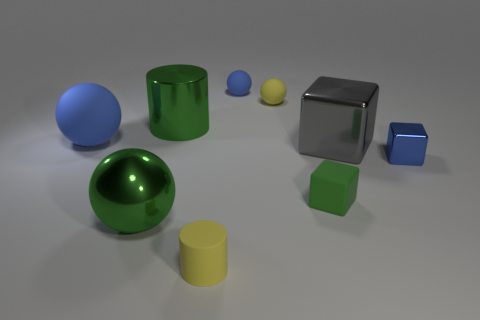Is the shape of the blue object that is to the left of the small blue matte ball the same as the yellow object that is behind the tiny yellow cylinder?
Ensure brevity in your answer.  Yes. What shape is the big object right of the cylinder that is in front of the large gray shiny block?
Your answer should be compact. Cube. There is a shiny thing that is right of the tiny green cube and behind the tiny metal block; what size is it?
Your answer should be very brief. Large. Is the shape of the large blue thing the same as the yellow matte object behind the big green sphere?
Provide a succinct answer. Yes. There is a green object that is the same shape as the gray thing; what size is it?
Your answer should be compact. Small. There is a large cube; does it have the same color as the cylinder that is behind the yellow cylinder?
Ensure brevity in your answer.  No. What number of other things are there of the same size as the blue metal object?
Give a very brief answer. 4. The tiny yellow thing that is to the right of the blue rubber sphere that is on the right side of the large green metal object in front of the gray shiny block is what shape?
Your answer should be compact. Sphere. There is a yellow cylinder; is it the same size as the yellow rubber object behind the green matte block?
Provide a succinct answer. Yes. There is a rubber object that is both in front of the tiny metal object and to the left of the small matte cube; what is its color?
Provide a short and direct response. Yellow. 